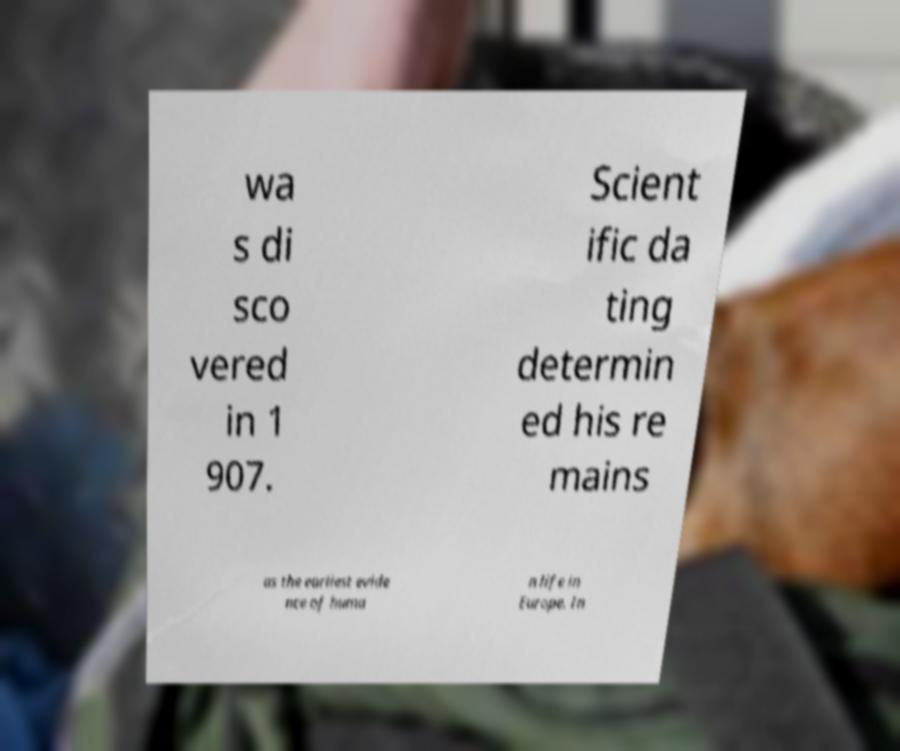Could you assist in decoding the text presented in this image and type it out clearly? wa s di sco vered in 1 907. Scient ific da ting determin ed his re mains as the earliest evide nce of huma n life in Europe. In 